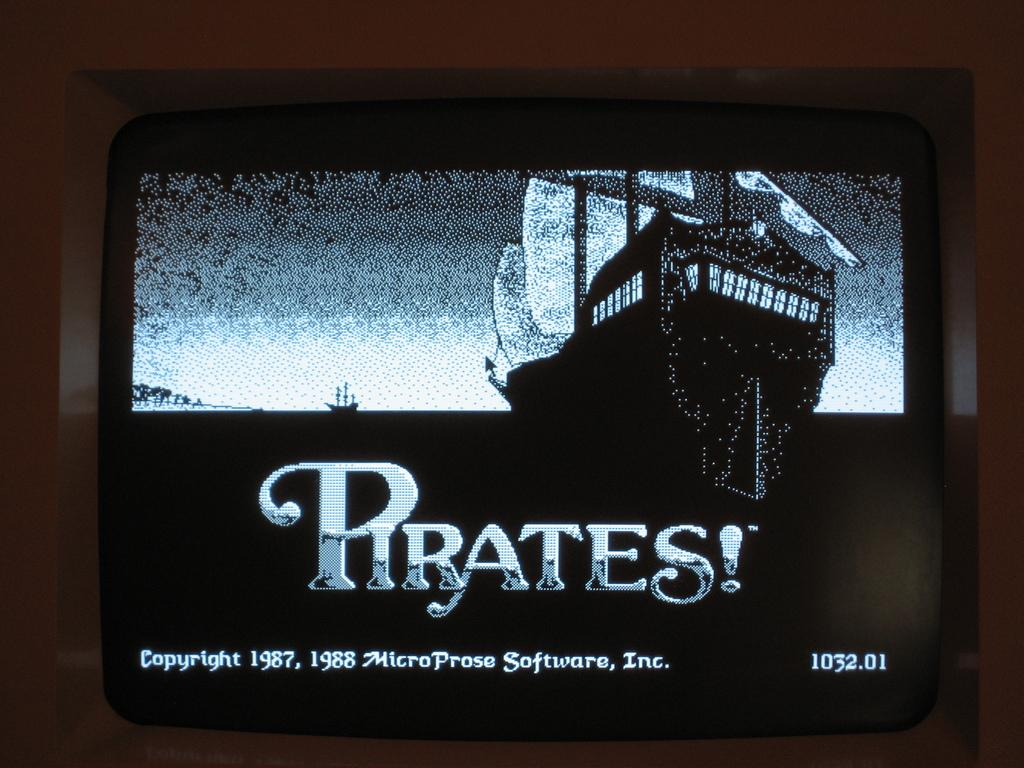<image>
Provide a brief description of the given image. A screen shows the software for Pirates in black and white. 